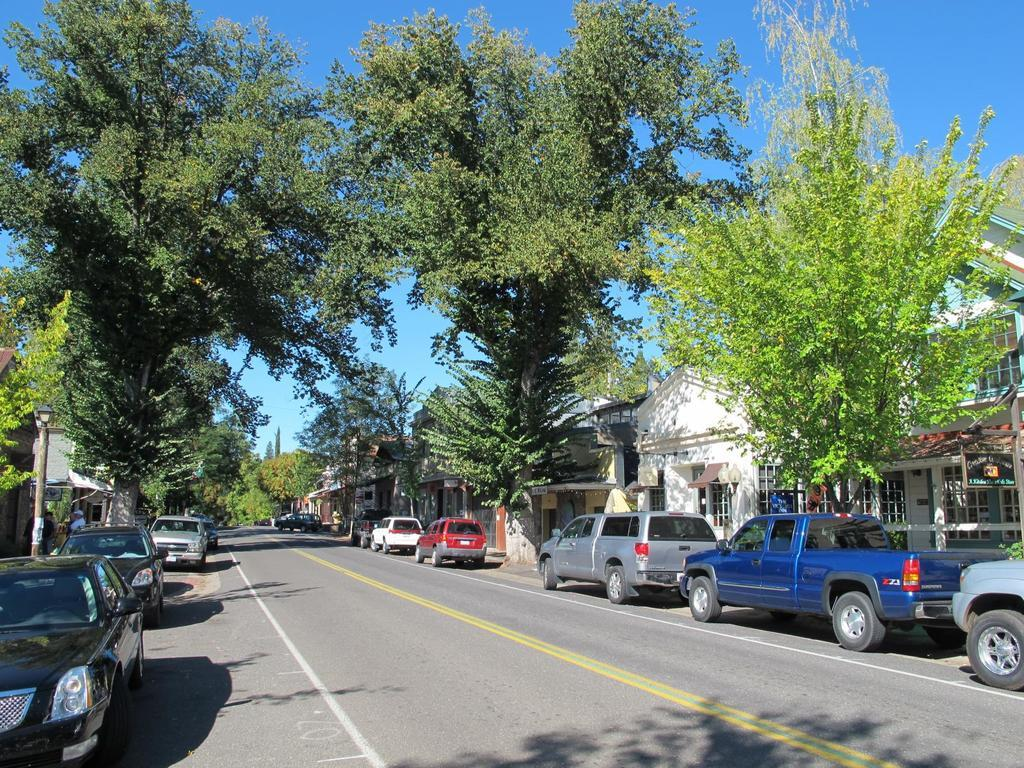What can be seen at the top of the image? The sky is visible in the image. What is located on either side of the road in the image? There are trees and houses on either side of the road. What type of vehicles are present on the road in the image? There are cars on the road. Can you tell me how many cows are grazing on the side of the road in the image? There are no cows present in the image; it features trees and houses on either side of the road. What type of band is performing on the side of the road in the image? There is no band present in the image; it features cars on the road and trees and houses on either side of the road. 